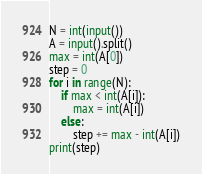<code> <loc_0><loc_0><loc_500><loc_500><_Python_>N = int(input())
A = input().split()
max = int(A[0])
step = 0
for i in range(N):
    if max < int(A[i]):
        max = int(A[i])
    else:
        step += max - int(A[i])
print(step)</code> 